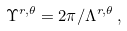Convert formula to latex. <formula><loc_0><loc_0><loc_500><loc_500>\Upsilon ^ { r , \theta } = 2 \pi / \Lambda ^ { r , \theta } \, ,</formula> 